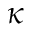<formula> <loc_0><loc_0><loc_500><loc_500>\kappa</formula> 